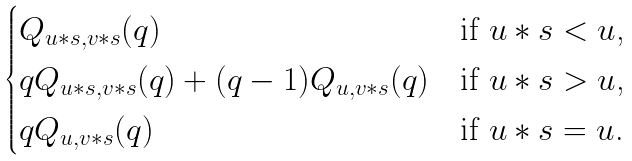Convert formula to latex. <formula><loc_0><loc_0><loc_500><loc_500>\begin{cases} Q _ { u * s , v * s } ( q ) & \text {if $u*s<u$,} \\ q Q _ { u * s , v * s } ( q ) + ( q - 1 ) Q _ { u , v * s } ( q ) & \text {if $u*s >u$,} \\ q Q _ { u , v * s } ( q ) & \text {if $u*s = u$.} \end{cases}</formula> 